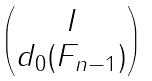<formula> <loc_0><loc_0><loc_500><loc_500>\begin{pmatrix} I \\ d _ { 0 } ( F _ { n - 1 } ) \end{pmatrix}</formula> 